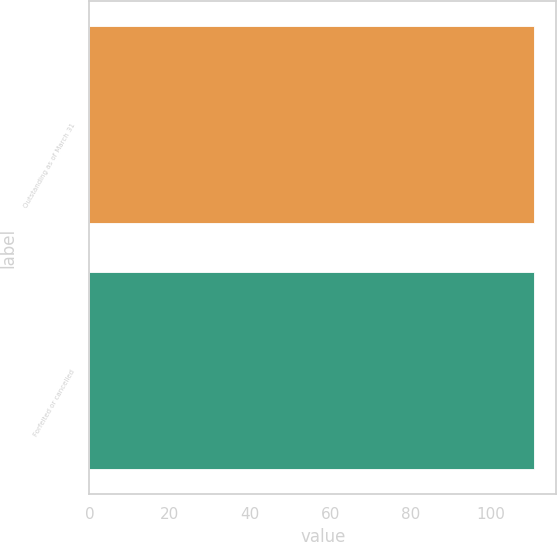<chart> <loc_0><loc_0><loc_500><loc_500><bar_chart><fcel>Outstanding as of March 31<fcel>Forfeited or cancelled<nl><fcel>110.71<fcel>110.61<nl></chart> 